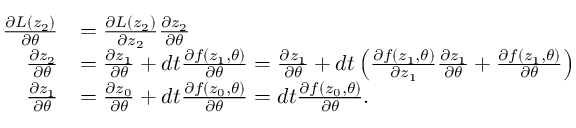<formula> <loc_0><loc_0><loc_500><loc_500>\begin{array} { r l } { \frac { \partial L ( z _ { 2 } ) } { \partial \theta } } & { = \frac { \partial L ( z _ { 2 } ) } { \partial z _ { 2 } } \frac { \partial z _ { 2 } } { \partial \theta } } \\ { \frac { \partial z _ { 2 } } { \partial \theta } } & { = \frac { \partial z _ { 1 } } { \partial \theta } + d t \frac { \partial f ( z _ { 1 } , \theta ) } { \partial \theta } = \frac { \partial z _ { 1 } } { \partial \theta } + d t \left ( \frac { \partial f ( z _ { 1 } , \theta ) } { \partial z _ { 1 } } \frac { \partial z _ { 1 } } { \partial \theta } + \frac { \partial f ( z _ { 1 } , \theta ) } { \partial \theta } \right ) } \\ { \frac { \partial z _ { 1 } } { \partial \theta } } & { = \frac { \partial z _ { 0 } } { \partial \theta } + d t \frac { \partial f ( z _ { 0 } , \theta ) } { \partial \theta } = d t \frac { \partial f ( z _ { 0 } , \theta ) } { \partial \theta } . } \end{array}</formula> 